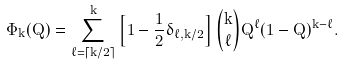Convert formula to latex. <formula><loc_0><loc_0><loc_500><loc_500>\Phi _ { k } ( Q ) = \sum _ { \ell = \lceil k / 2 \rceil } ^ { k } \left [ 1 - \frac { 1 } { 2 } \delta _ { \ell , k / 2 } \right ] \binom { k } { \ell } Q ^ { \ell } ( 1 - Q ) ^ { k - \ell } .</formula> 